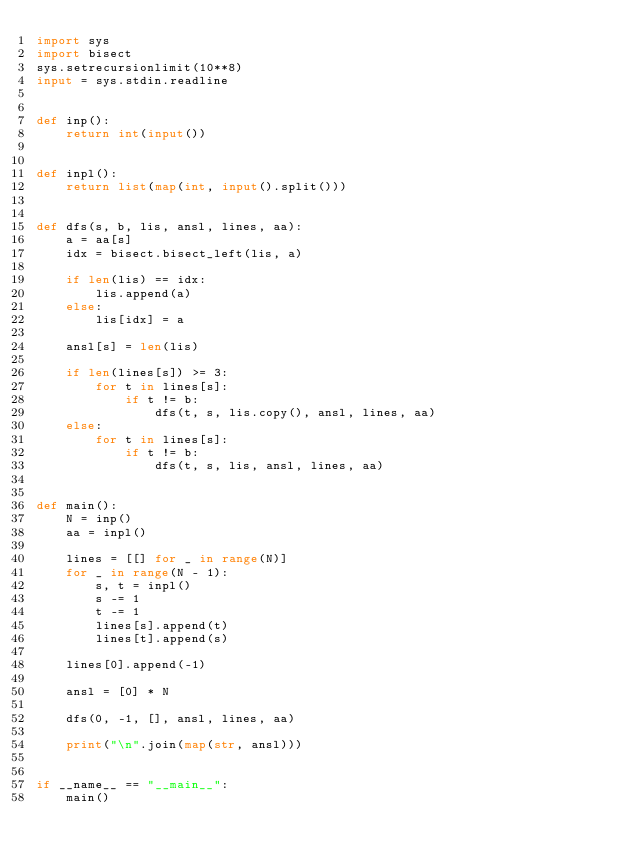Convert code to text. <code><loc_0><loc_0><loc_500><loc_500><_Python_>import sys
import bisect
sys.setrecursionlimit(10**8)
input = sys.stdin.readline


def inp():
    return int(input())


def inpl():
    return list(map(int, input().split()))


def dfs(s, b, lis, ansl, lines, aa):
    a = aa[s]
    idx = bisect.bisect_left(lis, a)

    if len(lis) == idx:
        lis.append(a)
    else:
        lis[idx] = a

    ansl[s] = len(lis)

    if len(lines[s]) >= 3:
        for t in lines[s]:
            if t != b:
                dfs(t, s, lis.copy(), ansl, lines, aa)
    else:
        for t in lines[s]:
            if t != b:
                dfs(t, s, lis, ansl, lines, aa)


def main():
    N = inp()
    aa = inpl()

    lines = [[] for _ in range(N)]
    for _ in range(N - 1):
        s, t = inpl()
        s -= 1
        t -= 1
        lines[s].append(t)
        lines[t].append(s)

    lines[0].append(-1)

    ansl = [0] * N

    dfs(0, -1, [], ansl, lines, aa)

    print("\n".join(map(str, ansl)))


if __name__ == "__main__":
    main()
</code> 